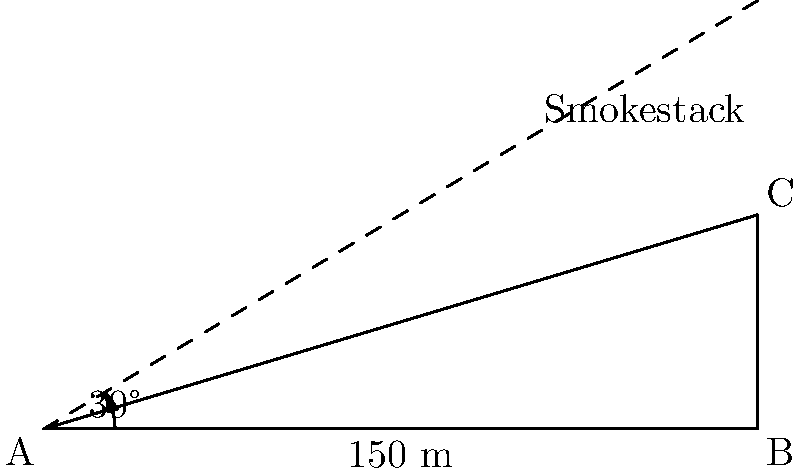An environmental engineer needs to estimate the height of a factory smokestack for emissions monitoring. Standing 150 meters away from the base of the smokestack, they measure the angle of elevation to the top of the stack to be 30°. Using this information, calculate the approximate height of the smokestack to the nearest meter. Let's approach this step-by-step:

1) We can model this scenario as a right-angled triangle, where:
   - The base of the triangle is the distance from the engineer to the smokestack (150 m)
   - The height of the triangle is the height of the smokestack (what we're solving for)
   - The angle between the base and the hypotenuse is 30°

2) In this right-angled triangle, we know:
   - The adjacent side (base) = 150 m
   - The angle = 30°
   - We need to find the opposite side (height)

3) The trigonometric ratio that relates the opposite side to the adjacent side is the tangent:

   $$\tan \theta = \frac{\text{opposite}}{\text{adjacent}}$$

4) Substituting our known values:

   $$\tan 30° = \frac{\text{height}}{150}$$

5) Rearranging to solve for height:

   $$\text{height} = 150 \times \tan 30°$$

6) We know that $\tan 30° = \frac{1}{\sqrt{3}} \approx 0.577$

7) Therefore:

   $$\text{height} = 150 \times 0.577 \approx 86.6 \text{ m}$$

8) Rounding to the nearest meter:

   $$\text{height} \approx 87 \text{ m}$$
Answer: 87 m 